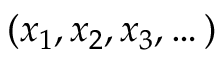Convert formula to latex. <formula><loc_0><loc_0><loc_500><loc_500>( x _ { 1 } , x _ { 2 } , x _ { 3 } , \dots )</formula> 